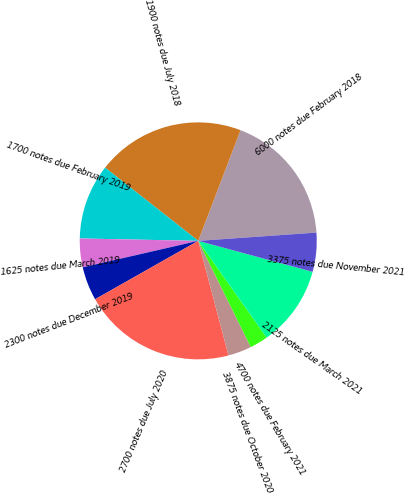Convert chart. <chart><loc_0><loc_0><loc_500><loc_500><pie_chart><fcel>6000 notes due February 2018<fcel>1900 notes due July 2018<fcel>1700 notes due February 2019<fcel>1625 notes due March 2019<fcel>2300 notes due December 2019<fcel>2700 notes due July 2020<fcel>3875 notes due October 2020<fcel>4700 notes due February 2021<fcel>2125 notes due March 2021<fcel>3375 notes due November 2021<nl><fcel>18.08%<fcel>20.2%<fcel>10.28%<fcel>3.91%<fcel>4.61%<fcel>20.91%<fcel>3.2%<fcel>2.49%<fcel>10.99%<fcel>5.32%<nl></chart> 